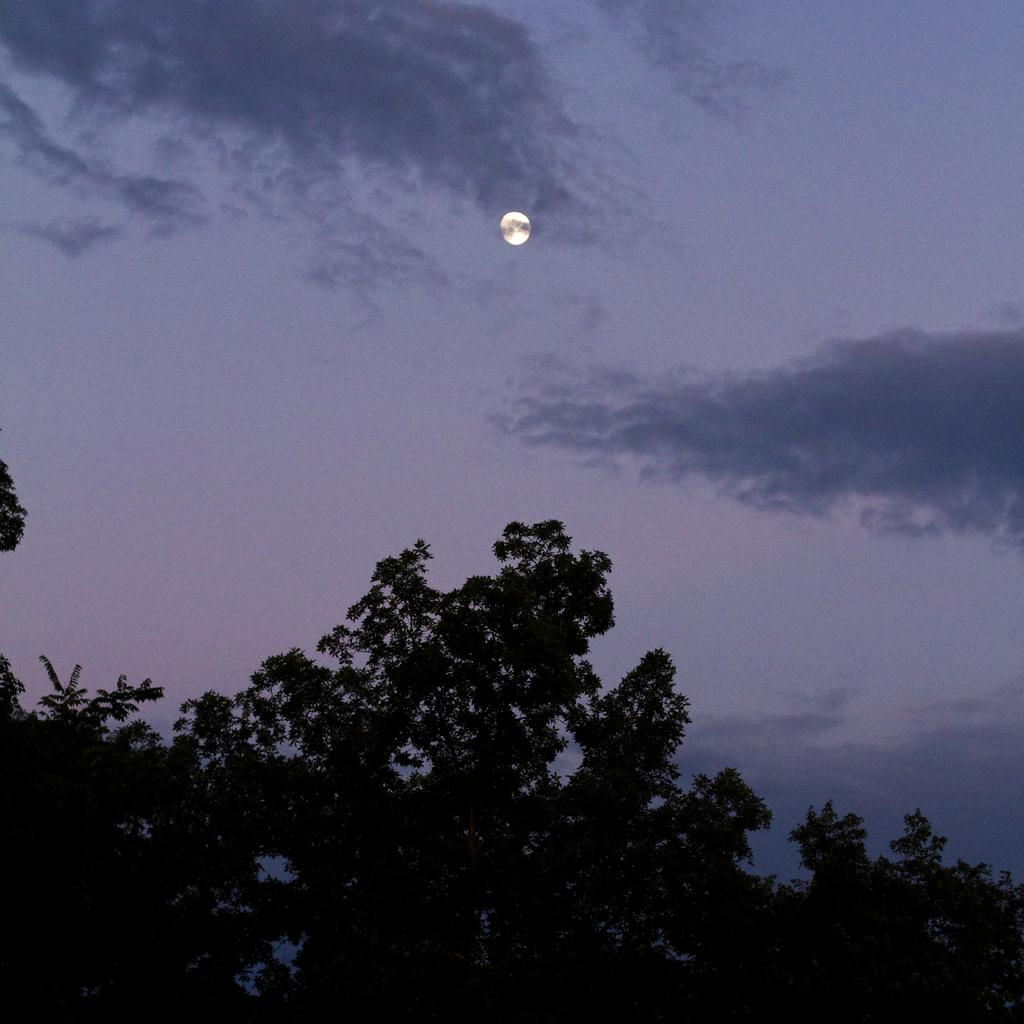What time of day was the image taken? The image was taken at night. What can be seen at the bottom of the image? There are trees at the bottom of the image. What celestial body is visible in the sky at the top of the image? The moon is visible in the sky at the top of the image. What type of level can be seen on the playground in the image? There is no level or playground present in the image. What is the condition of the throat of the person in the image? There is no person present in the image, so it is not possible to determine the condition of their throat. 